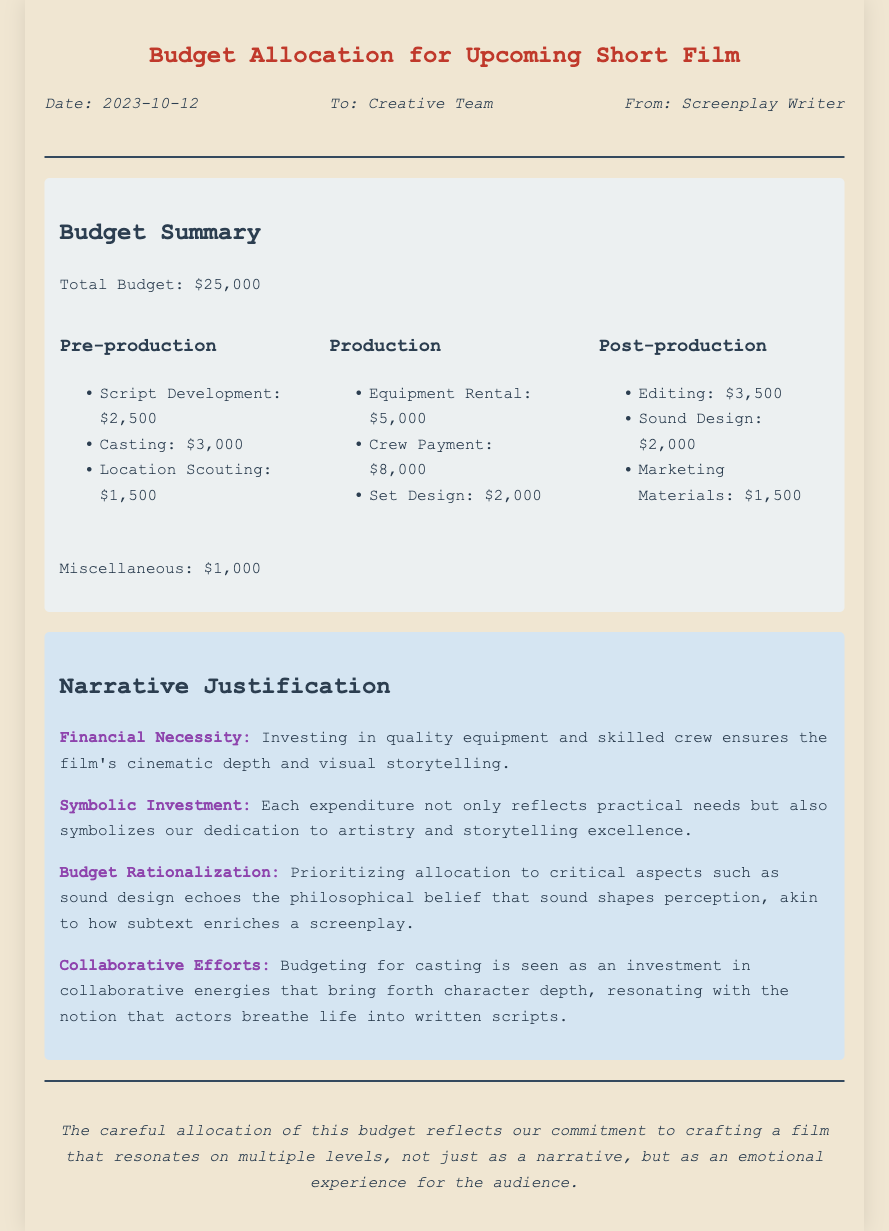what is the total budget? The total budget is explicitly mentioned in the document as $25,000.
Answer: $25,000 how much is allocated to crew payment? The document lists crew payment under the Production category as $8,000.
Answer: $8,000 what is the expenditure for sound design? Sound design is detailed in the Post-production section with an expenditure of $2,000.
Answer: $2,000 which category has the highest expenditure? By analyzing the expenditures, Production has the highest total, specifically $15,000.
Answer: Production what does the term "Budget Rationalization" symbolize? The term emphasizes the thematic connection between budgeting and storytelling in the film, specifically around sound design.
Answer: Sound shapes perception what is the purpose of casting in the budget? Casting is presented as an investment in collaborative energies that enrich character depth and script life.
Answer: Collaborative energies when was the memo created? The memo indicates the date of creation as October 12, 2023.
Answer: 2023-10-12 what does the narrative justification suggest about equipment investment? The narrative suggests that investment in quality equipment enhances cinematic depth and visual storytelling.
Answer: Cinematic depth what is marked as miscellaneous expenses? The document specifies a miscellaneous expense amounting to $1,000.
Answer: $1,000 